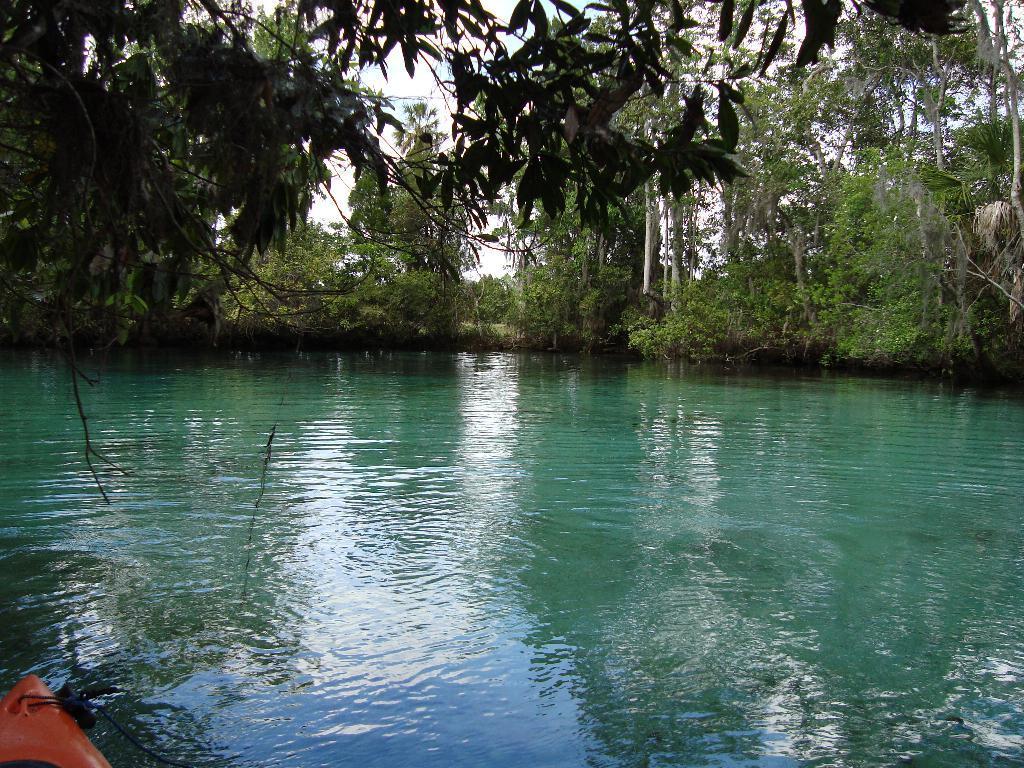How would you summarize this image in a sentence or two? In this picture we can see water. There is an object in the bottom left. We can see a few trees in the background. 